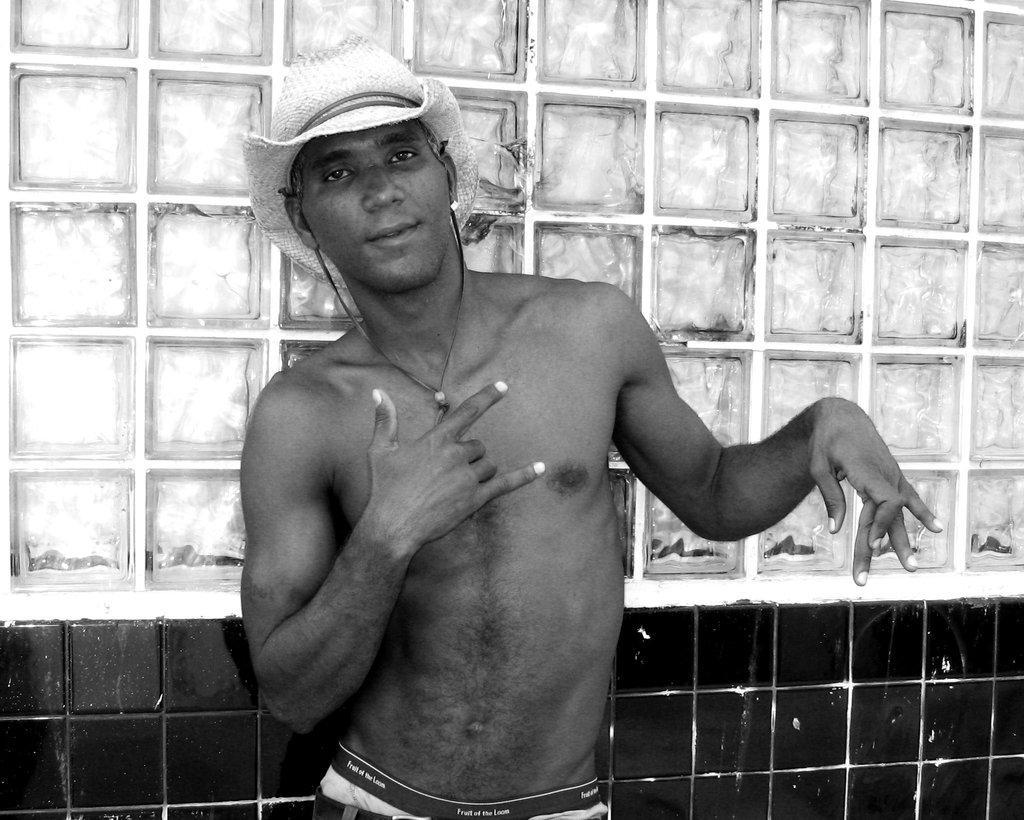Please provide a concise description of this image. This man wore hat and looking forward. Wall with tiles. 